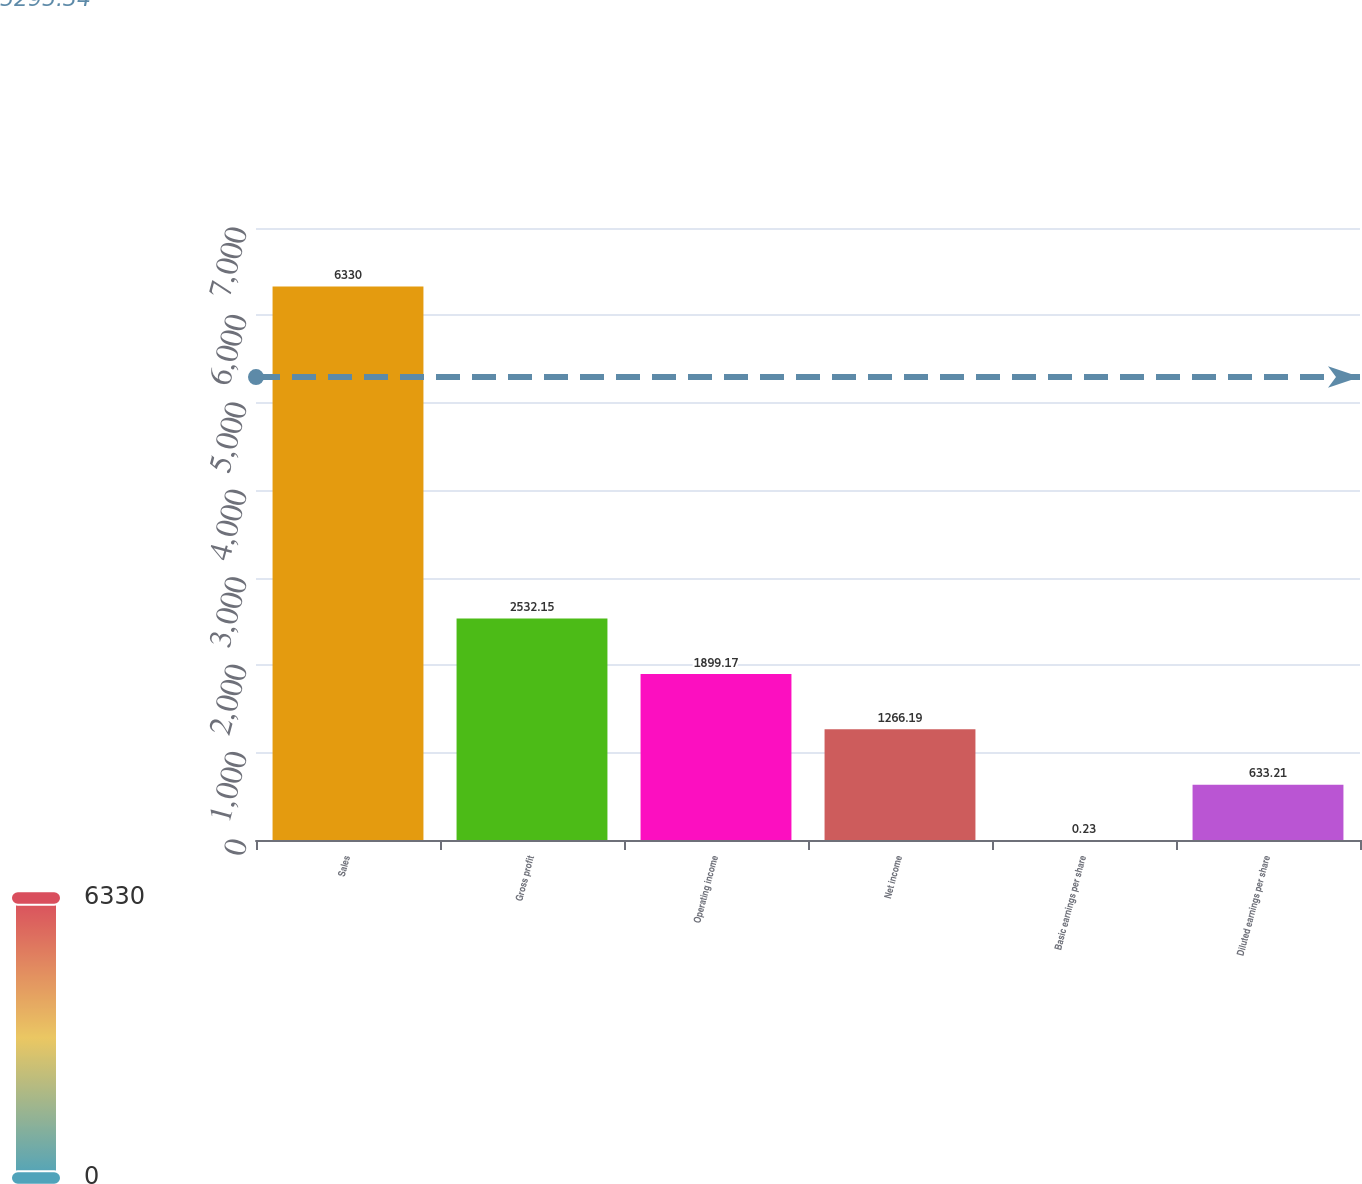<chart> <loc_0><loc_0><loc_500><loc_500><bar_chart><fcel>Sales<fcel>Gross profit<fcel>Operating income<fcel>Net income<fcel>Basic earnings per share<fcel>Diluted earnings per share<nl><fcel>6330<fcel>2532.15<fcel>1899.17<fcel>1266.19<fcel>0.23<fcel>633.21<nl></chart> 